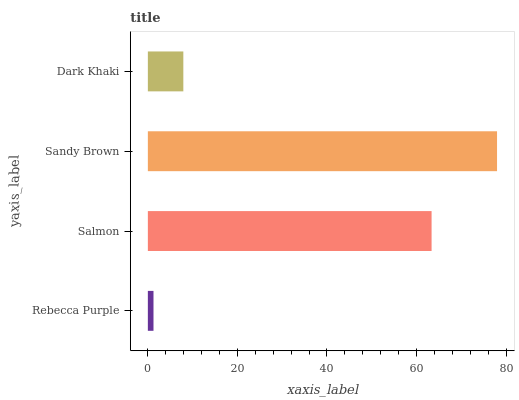Is Rebecca Purple the minimum?
Answer yes or no. Yes. Is Sandy Brown the maximum?
Answer yes or no. Yes. Is Salmon the minimum?
Answer yes or no. No. Is Salmon the maximum?
Answer yes or no. No. Is Salmon greater than Rebecca Purple?
Answer yes or no. Yes. Is Rebecca Purple less than Salmon?
Answer yes or no. Yes. Is Rebecca Purple greater than Salmon?
Answer yes or no. No. Is Salmon less than Rebecca Purple?
Answer yes or no. No. Is Salmon the high median?
Answer yes or no. Yes. Is Dark Khaki the low median?
Answer yes or no. Yes. Is Dark Khaki the high median?
Answer yes or no. No. Is Rebecca Purple the low median?
Answer yes or no. No. 